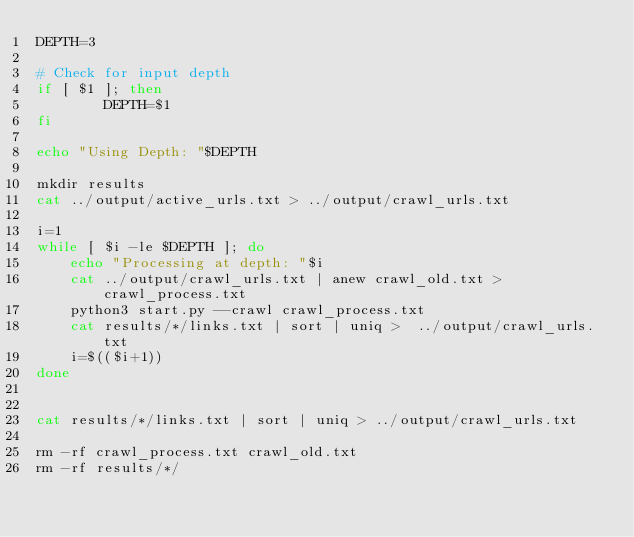<code> <loc_0><loc_0><loc_500><loc_500><_Bash_>DEPTH=3

# Check for input depth
if [ $1 ]; then
        DEPTH=$1
fi

echo "Using Depth: "$DEPTH

mkdir results
cat ../output/active_urls.txt > ../output/crawl_urls.txt

i=1
while [ $i -le $DEPTH ]; do
    echo "Processing at depth: "$i
    cat ../output/crawl_urls.txt | anew crawl_old.txt > crawl_process.txt
    python3 start.py --crawl crawl_process.txt
    cat results/*/links.txt | sort | uniq >  ../output/crawl_urls.txt
    i=$(($i+1))
done


cat results/*/links.txt | sort | uniq > ../output/crawl_urls.txt

rm -rf crawl_process.txt crawl_old.txt
rm -rf results/*/
</code> 